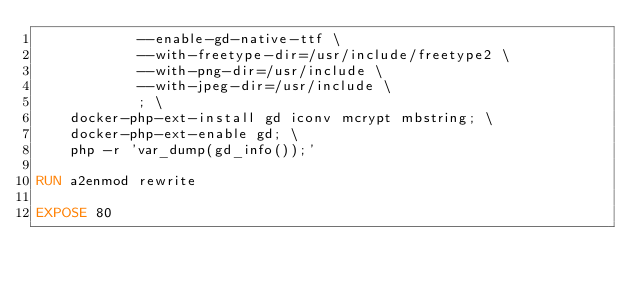<code> <loc_0><loc_0><loc_500><loc_500><_Dockerfile_>            --enable-gd-native-ttf \
            --with-freetype-dir=/usr/include/freetype2 \
            --with-png-dir=/usr/include \
            --with-jpeg-dir=/usr/include \
            ; \
    docker-php-ext-install gd iconv mcrypt mbstring; \
    docker-php-ext-enable gd; \
    php -r 'var_dump(gd_info());'

RUN a2enmod rewrite

EXPOSE 80
</code> 